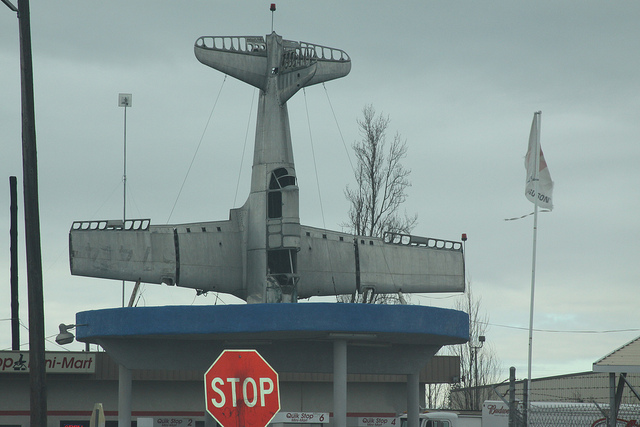<image>Where is the statue located? I don't know exactly where the statue is located. It could be on a rooftop, at an intersection, in a museum or behind a stop sign. Where is the statue located? It is unclear where the statue is located. It can be seen on the rooftop, mini mart, or at the intersection. 